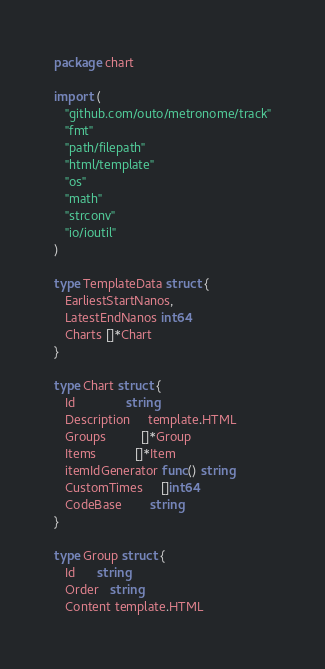Convert code to text. <code><loc_0><loc_0><loc_500><loc_500><_Go_>package chart

import (
   "github.com/outo/metronome/track"
   "fmt"
   "path/filepath"
   "html/template"
   "os"
   "math"
   "strconv"
   "io/ioutil"
)

type TemplateData struct {
   EarliestStartNanos,
   LatestEndNanos int64
   Charts []*Chart
}

type Chart struct {
   Id              string
   Description     template.HTML
   Groups          []*Group
   Items           []*Item
   itemIdGenerator func() string
   CustomTimes     []int64
   CodeBase        string
}

type Group struct {
   Id      string
   Order   string
   Content template.HTML</code> 